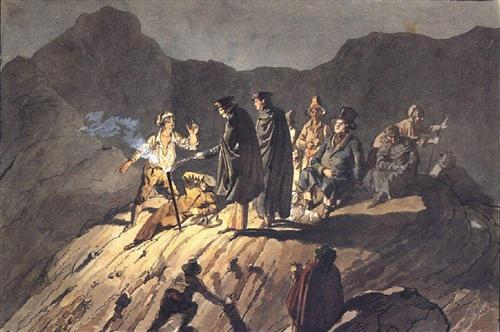What can you tell me about the emotions portrayed in this scene? The emotions in this scene are intense and varied. The central figures, cloaked in darkness, appear to be in a state of confrontation or decision. The lighting casts a dramatic effect, highlighting the tension and anticipation. The figures in the background seem to be observing with a mix of concern and curiosity, adding to the overall suspense. The dramatic use of shadows and light plays a crucial role in conveying a sense of urgency and emotional gravity. 